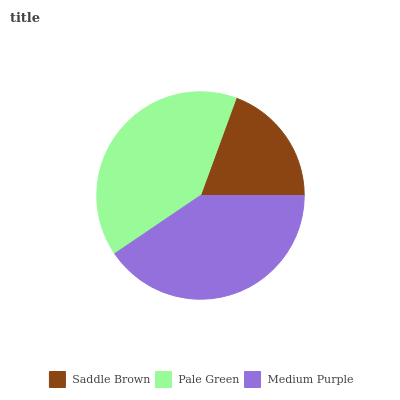Is Saddle Brown the minimum?
Answer yes or no. Yes. Is Medium Purple the maximum?
Answer yes or no. Yes. Is Pale Green the minimum?
Answer yes or no. No. Is Pale Green the maximum?
Answer yes or no. No. Is Pale Green greater than Saddle Brown?
Answer yes or no. Yes. Is Saddle Brown less than Pale Green?
Answer yes or no. Yes. Is Saddle Brown greater than Pale Green?
Answer yes or no. No. Is Pale Green less than Saddle Brown?
Answer yes or no. No. Is Pale Green the high median?
Answer yes or no. Yes. Is Pale Green the low median?
Answer yes or no. Yes. Is Medium Purple the high median?
Answer yes or no. No. Is Saddle Brown the low median?
Answer yes or no. No. 